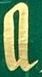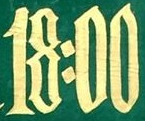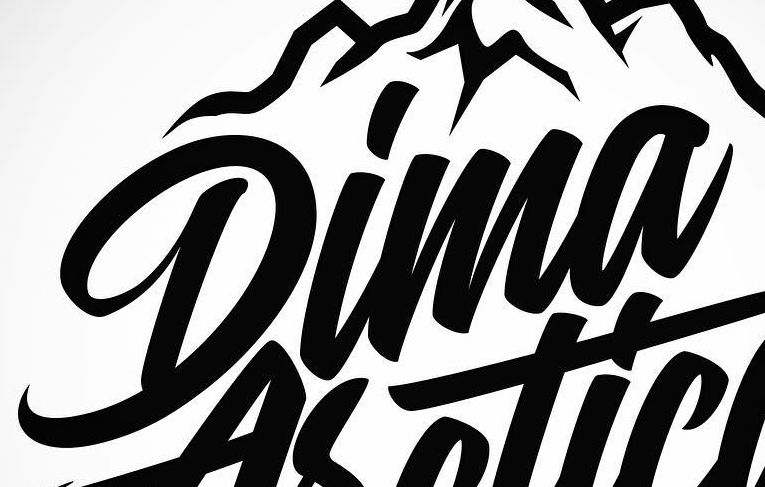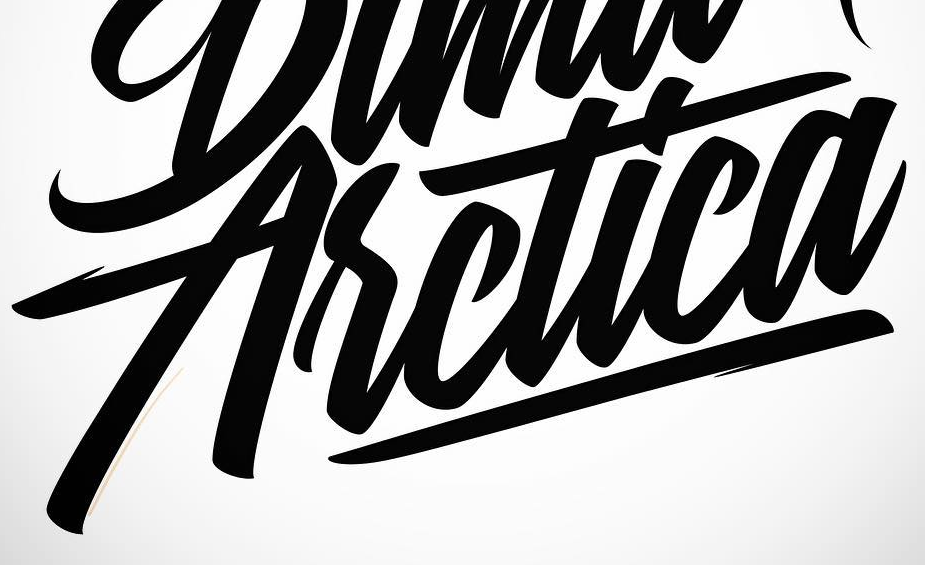Read the text from these images in sequence, separated by a semicolon. a; 18:00; Dima; Asctica 